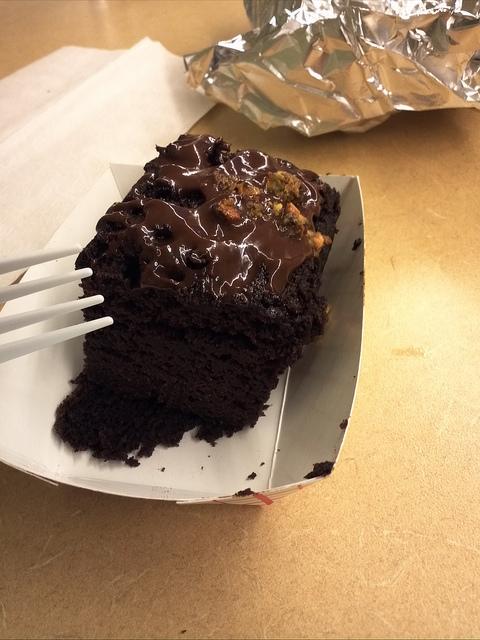What flavor cake is this?
Keep it brief. Chocolate. What kind of container is the cake in?
Be succinct. Paper. What is the fork made out of?
Write a very short answer. Plastic. 